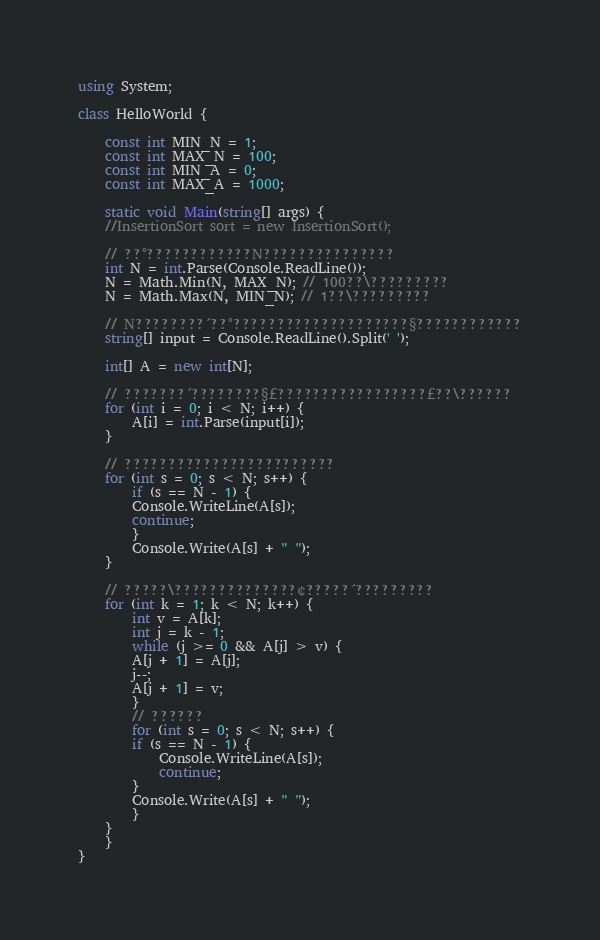<code> <loc_0><loc_0><loc_500><loc_500><_C#_>using System;

class HelloWorld {

    const int MIN_N = 1;
    const int MAX_N = 100;
    const int MIN_A = 0;
    const int MAX_A = 1000;

    static void Main(string[] args) {
	//InsertionSort sort = new InsertionSort();

	// ??°????????????N???????????????
	int N = int.Parse(Console.ReadLine());
	N = Math.Min(N, MAX_N); // 100??\?????????
	N = Math.Max(N, MIN_N); // 1??\?????????

	// N????????´??°????????????????????§????????????
	string[] input = Console.ReadLine().Split(' ');

	int[] A = new int[N];

	// ???????´????????§£?????????????????£??\??????
	for (int i = 0; i < N; i++) {
	    A[i] = int.Parse(input[i]);
	}

	// ????????????????????????
	for (int s = 0; s < N; s++) {
	    if (s == N - 1) {
		Console.WriteLine(A[s]);
		continue;
	    }
	    Console.Write(A[s] + " ");
	}

	// ?????\??????????????¢?????´?????????
	for (int k = 1; k < N; k++) {
	    int v = A[k];
	    int j = k - 1;
	    while (j >= 0 && A[j] > v) {
		A[j + 1] = A[j];
		j--;
		A[j + 1] = v;
	    }
	    // ??????
	    for (int s = 0; s < N; s++) {
		if (s == N - 1) {
		    Console.WriteLine(A[s]);
		    continue;
		}
		Console.Write(A[s] + " ");
	    }
	}
    }
}</code> 